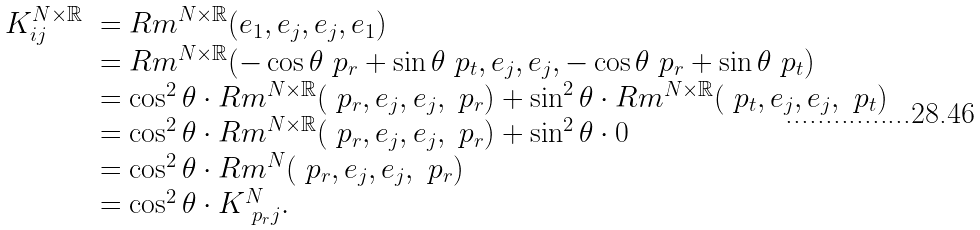<formula> <loc_0><loc_0><loc_500><loc_500>\begin{array} { c l } K _ { i j } ^ { N \times \mathbb { R } } & = { R m } ^ { N \times \mathbb { R } } ( e _ { 1 } , e _ { j } , e _ { j } , e _ { 1 } ) \\ & = R m ^ { N \times \mathbb { R } } ( - \cos { \theta } \ p _ { r } + \sin { \theta } \ p _ { t } , e _ { j } , e _ { j } , - \cos { \theta } \ p _ { r } + \sin { \theta } \ p _ { t } ) \\ & = \cos ^ { 2 } { \theta } \cdot R m ^ { N \times \mathbb { R } } ( \ p _ { r } , e _ { j } , e _ { j } , \ p _ { r } ) + \sin ^ { 2 } { \theta } \cdot R m ^ { N \times \mathbb { R } } ( \ p _ { t } , e _ { j } , e _ { j } , \ p _ { t } ) \\ & = \cos ^ { 2 } { \theta } \cdot R m ^ { N \times \mathbb { R } } ( \ p _ { r } , e _ { j } , e _ { j } , \ p _ { r } ) + \sin ^ { 2 } { \theta } \cdot 0 \\ & = \cos ^ { 2 } { \theta } \cdot R m ^ { N } ( \ p _ { r } , e _ { j } , e _ { j } , \ p _ { r } ) \\ & = \cos ^ { 2 } { \theta } \cdot K _ { \ p _ { r } j } ^ { N } . \end{array}</formula> 